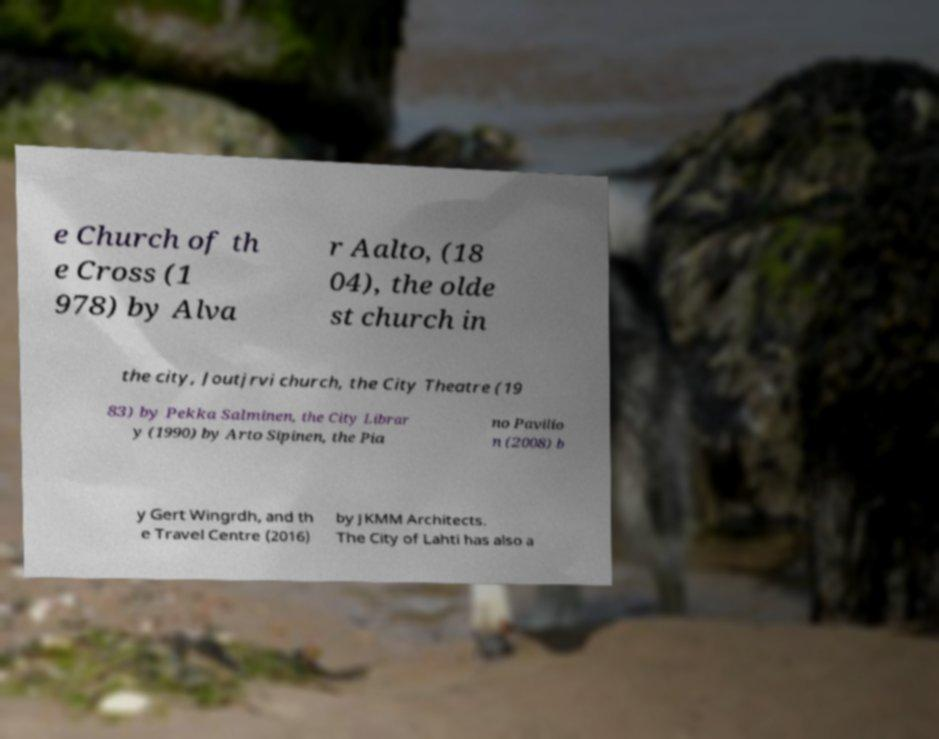What messages or text are displayed in this image? I need them in a readable, typed format. e Church of th e Cross (1 978) by Alva r Aalto, (18 04), the olde st church in the city, Joutjrvi church, the City Theatre (19 83) by Pekka Salminen, the City Librar y (1990) by Arto Sipinen, the Pia no Pavilio n (2008) b y Gert Wingrdh, and th e Travel Centre (2016) by JKMM Architects. The City of Lahti has also a 